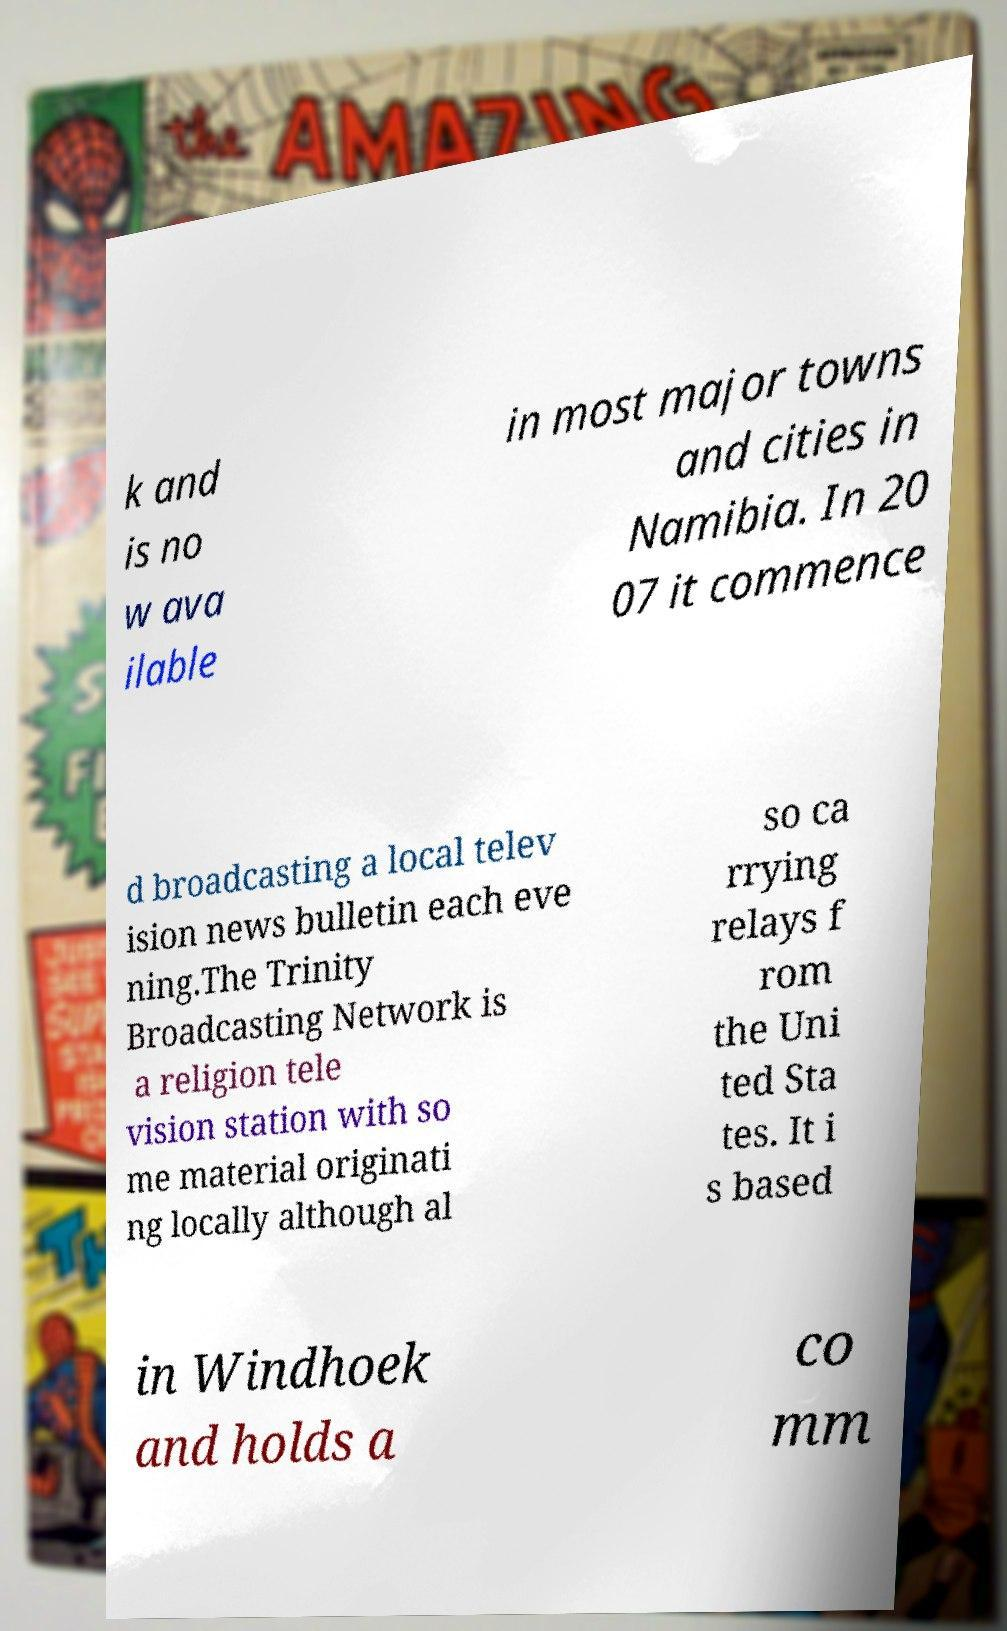What messages or text are displayed in this image? I need them in a readable, typed format. k and is no w ava ilable in most major towns and cities in Namibia. In 20 07 it commence d broadcasting a local telev ision news bulletin each eve ning.The Trinity Broadcasting Network is a religion tele vision station with so me material originati ng locally although al so ca rrying relays f rom the Uni ted Sta tes. It i s based in Windhoek and holds a co mm 